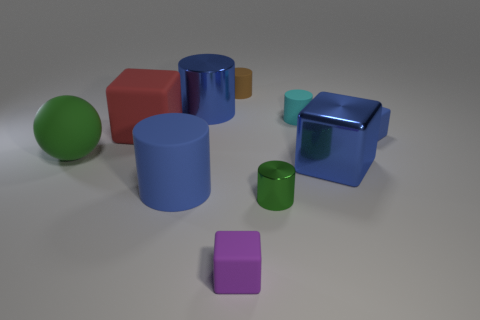Which object stands out the most to you, and why? The larger blue cube immediately draws attention due to its shinier surface and vibrant color. It contrasts with the other objects, which have a more muted finish, and its size, compared to the other shapes, also makes it a focal point. 